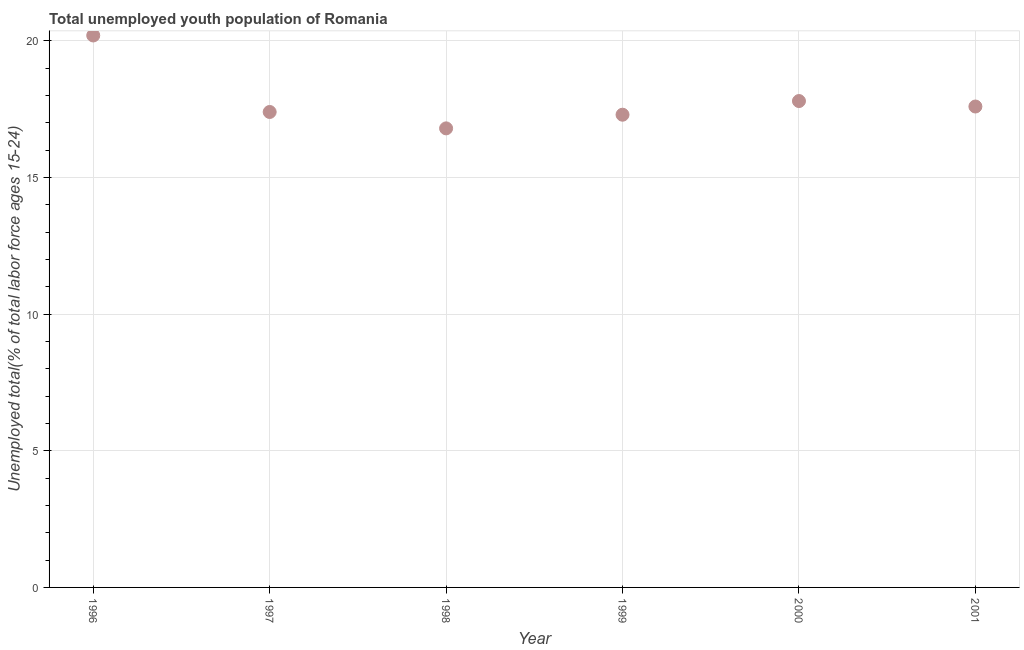What is the unemployed youth in 1997?
Your response must be concise. 17.4. Across all years, what is the maximum unemployed youth?
Offer a very short reply. 20.2. Across all years, what is the minimum unemployed youth?
Ensure brevity in your answer.  16.8. In which year was the unemployed youth maximum?
Ensure brevity in your answer.  1996. In which year was the unemployed youth minimum?
Offer a very short reply. 1998. What is the sum of the unemployed youth?
Make the answer very short. 107.1. What is the difference between the unemployed youth in 1999 and 2001?
Offer a very short reply. -0.3. What is the average unemployed youth per year?
Keep it short and to the point. 17.85. In how many years, is the unemployed youth greater than 4 %?
Your answer should be compact. 6. What is the ratio of the unemployed youth in 1996 to that in 1998?
Make the answer very short. 1.2. Is the difference between the unemployed youth in 2000 and 2001 greater than the difference between any two years?
Give a very brief answer. No. What is the difference between the highest and the second highest unemployed youth?
Your answer should be compact. 2.4. What is the difference between the highest and the lowest unemployed youth?
Make the answer very short. 3.4. Does the unemployed youth monotonically increase over the years?
Provide a short and direct response. No. How many dotlines are there?
Provide a succinct answer. 1. How many years are there in the graph?
Your answer should be compact. 6. What is the difference between two consecutive major ticks on the Y-axis?
Provide a short and direct response. 5. Are the values on the major ticks of Y-axis written in scientific E-notation?
Make the answer very short. No. Does the graph contain any zero values?
Offer a very short reply. No. Does the graph contain grids?
Provide a succinct answer. Yes. What is the title of the graph?
Provide a short and direct response. Total unemployed youth population of Romania. What is the label or title of the Y-axis?
Your answer should be very brief. Unemployed total(% of total labor force ages 15-24). What is the Unemployed total(% of total labor force ages 15-24) in 1996?
Keep it short and to the point. 20.2. What is the Unemployed total(% of total labor force ages 15-24) in 1997?
Provide a succinct answer. 17.4. What is the Unemployed total(% of total labor force ages 15-24) in 1998?
Offer a very short reply. 16.8. What is the Unemployed total(% of total labor force ages 15-24) in 1999?
Ensure brevity in your answer.  17.3. What is the Unemployed total(% of total labor force ages 15-24) in 2000?
Your response must be concise. 17.8. What is the Unemployed total(% of total labor force ages 15-24) in 2001?
Provide a succinct answer. 17.6. What is the difference between the Unemployed total(% of total labor force ages 15-24) in 1997 and 1999?
Give a very brief answer. 0.1. What is the difference between the Unemployed total(% of total labor force ages 15-24) in 1997 and 2001?
Make the answer very short. -0.2. What is the difference between the Unemployed total(% of total labor force ages 15-24) in 1998 and 2000?
Your answer should be very brief. -1. What is the difference between the Unemployed total(% of total labor force ages 15-24) in 1998 and 2001?
Your answer should be very brief. -0.8. What is the difference between the Unemployed total(% of total labor force ages 15-24) in 1999 and 2001?
Provide a succinct answer. -0.3. What is the difference between the Unemployed total(% of total labor force ages 15-24) in 2000 and 2001?
Provide a short and direct response. 0.2. What is the ratio of the Unemployed total(% of total labor force ages 15-24) in 1996 to that in 1997?
Ensure brevity in your answer.  1.16. What is the ratio of the Unemployed total(% of total labor force ages 15-24) in 1996 to that in 1998?
Provide a short and direct response. 1.2. What is the ratio of the Unemployed total(% of total labor force ages 15-24) in 1996 to that in 1999?
Make the answer very short. 1.17. What is the ratio of the Unemployed total(% of total labor force ages 15-24) in 1996 to that in 2000?
Ensure brevity in your answer.  1.14. What is the ratio of the Unemployed total(% of total labor force ages 15-24) in 1996 to that in 2001?
Your response must be concise. 1.15. What is the ratio of the Unemployed total(% of total labor force ages 15-24) in 1997 to that in 1998?
Your answer should be compact. 1.04. What is the ratio of the Unemployed total(% of total labor force ages 15-24) in 1997 to that in 2000?
Offer a very short reply. 0.98. What is the ratio of the Unemployed total(% of total labor force ages 15-24) in 1997 to that in 2001?
Your answer should be compact. 0.99. What is the ratio of the Unemployed total(% of total labor force ages 15-24) in 1998 to that in 1999?
Give a very brief answer. 0.97. What is the ratio of the Unemployed total(% of total labor force ages 15-24) in 1998 to that in 2000?
Provide a short and direct response. 0.94. What is the ratio of the Unemployed total(% of total labor force ages 15-24) in 1998 to that in 2001?
Give a very brief answer. 0.95. 